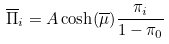<formula> <loc_0><loc_0><loc_500><loc_500>\overline { \Pi } _ { i } = A \cosh ( \overline { \mu } ) \frac { \pi _ { i } } { 1 - \pi _ { 0 } }</formula> 